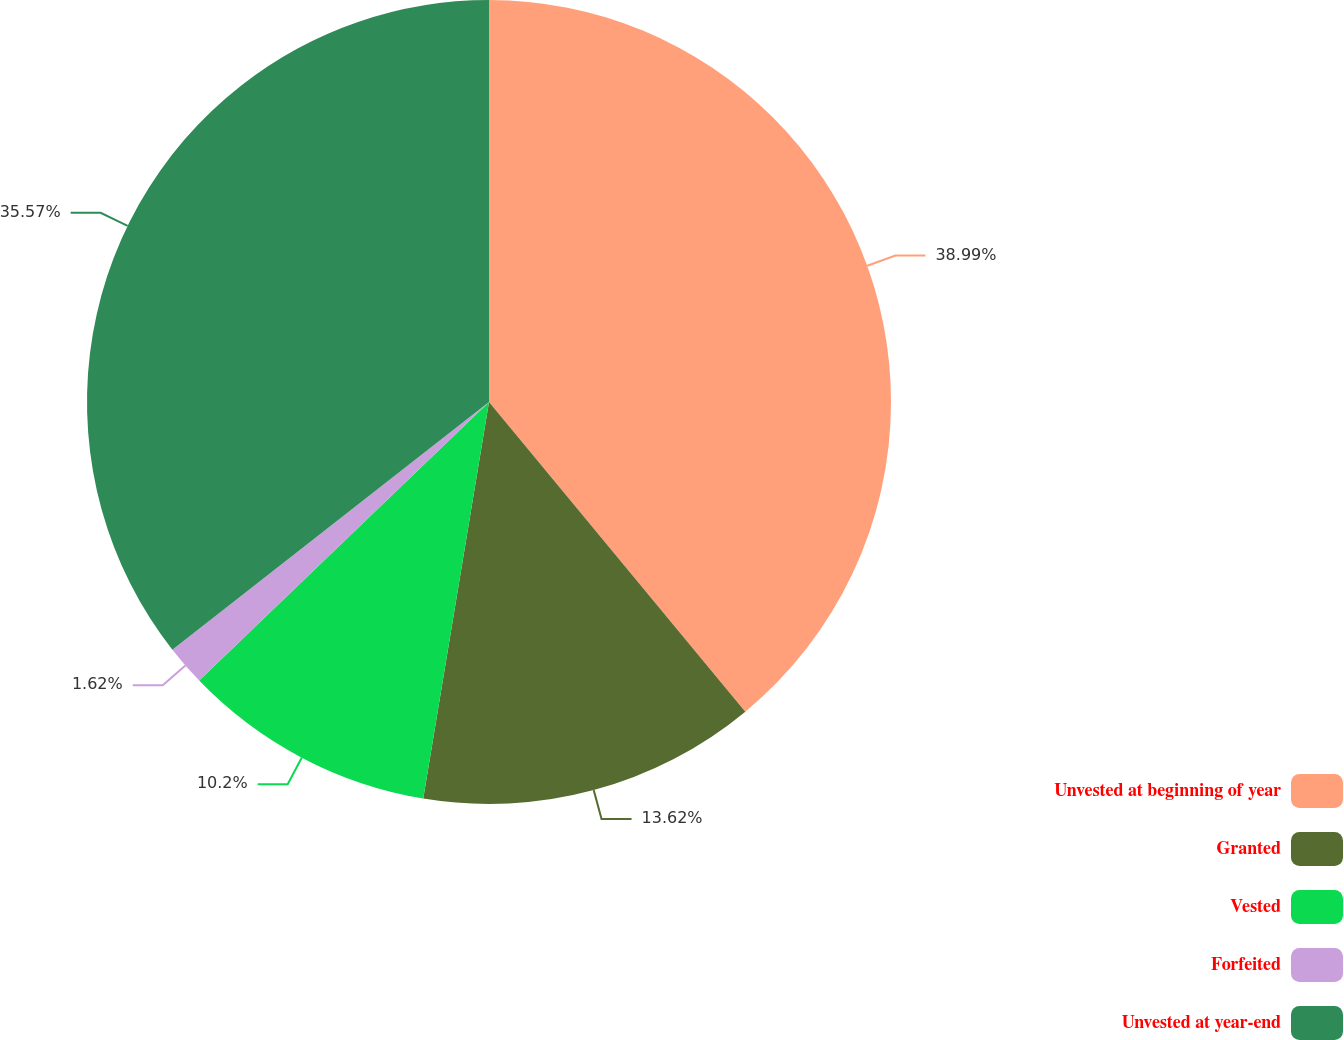Convert chart. <chart><loc_0><loc_0><loc_500><loc_500><pie_chart><fcel>Unvested at beginning of year<fcel>Granted<fcel>Vested<fcel>Forfeited<fcel>Unvested at year-end<nl><fcel>39.0%<fcel>13.62%<fcel>10.2%<fcel>1.62%<fcel>35.57%<nl></chart> 